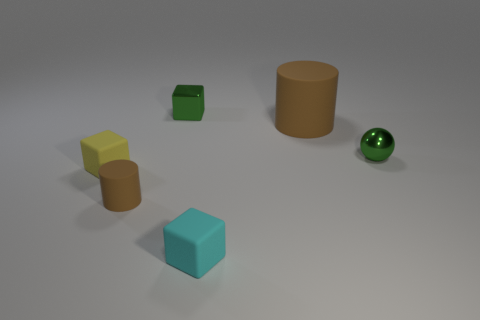Are there any other things of the same color as the big cylinder? Yes, there is a small sphere with a similar shade of green as the big cylinder. 